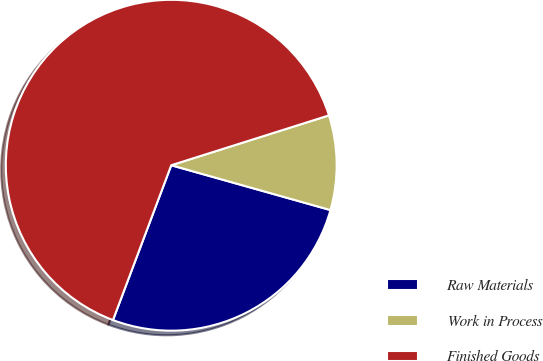Convert chart to OTSL. <chart><loc_0><loc_0><loc_500><loc_500><pie_chart><fcel>Raw Materials<fcel>Work in Process<fcel>Finished Goods<nl><fcel>26.36%<fcel>9.24%<fcel>64.4%<nl></chart> 